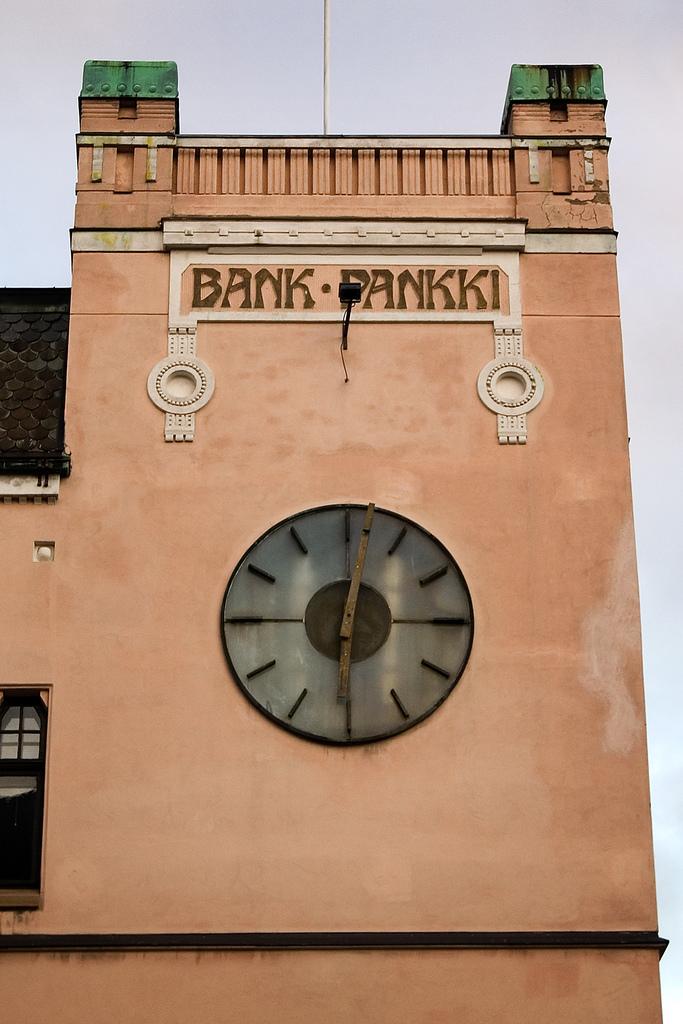What is the name of the building where the big clock is attached to?
Make the answer very short. Bank pankki. What time is shown on the clock?
Your answer should be compact. 6:02. 